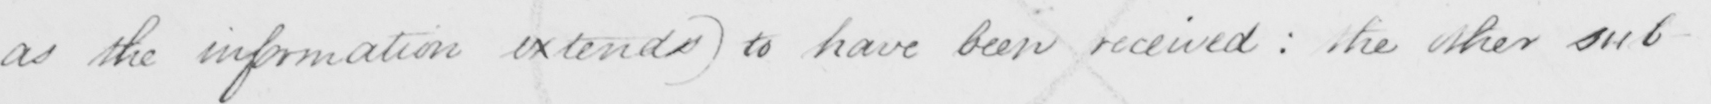Transcribe the text shown in this historical manuscript line. as the information extends )  to have been received :  the other sub- 